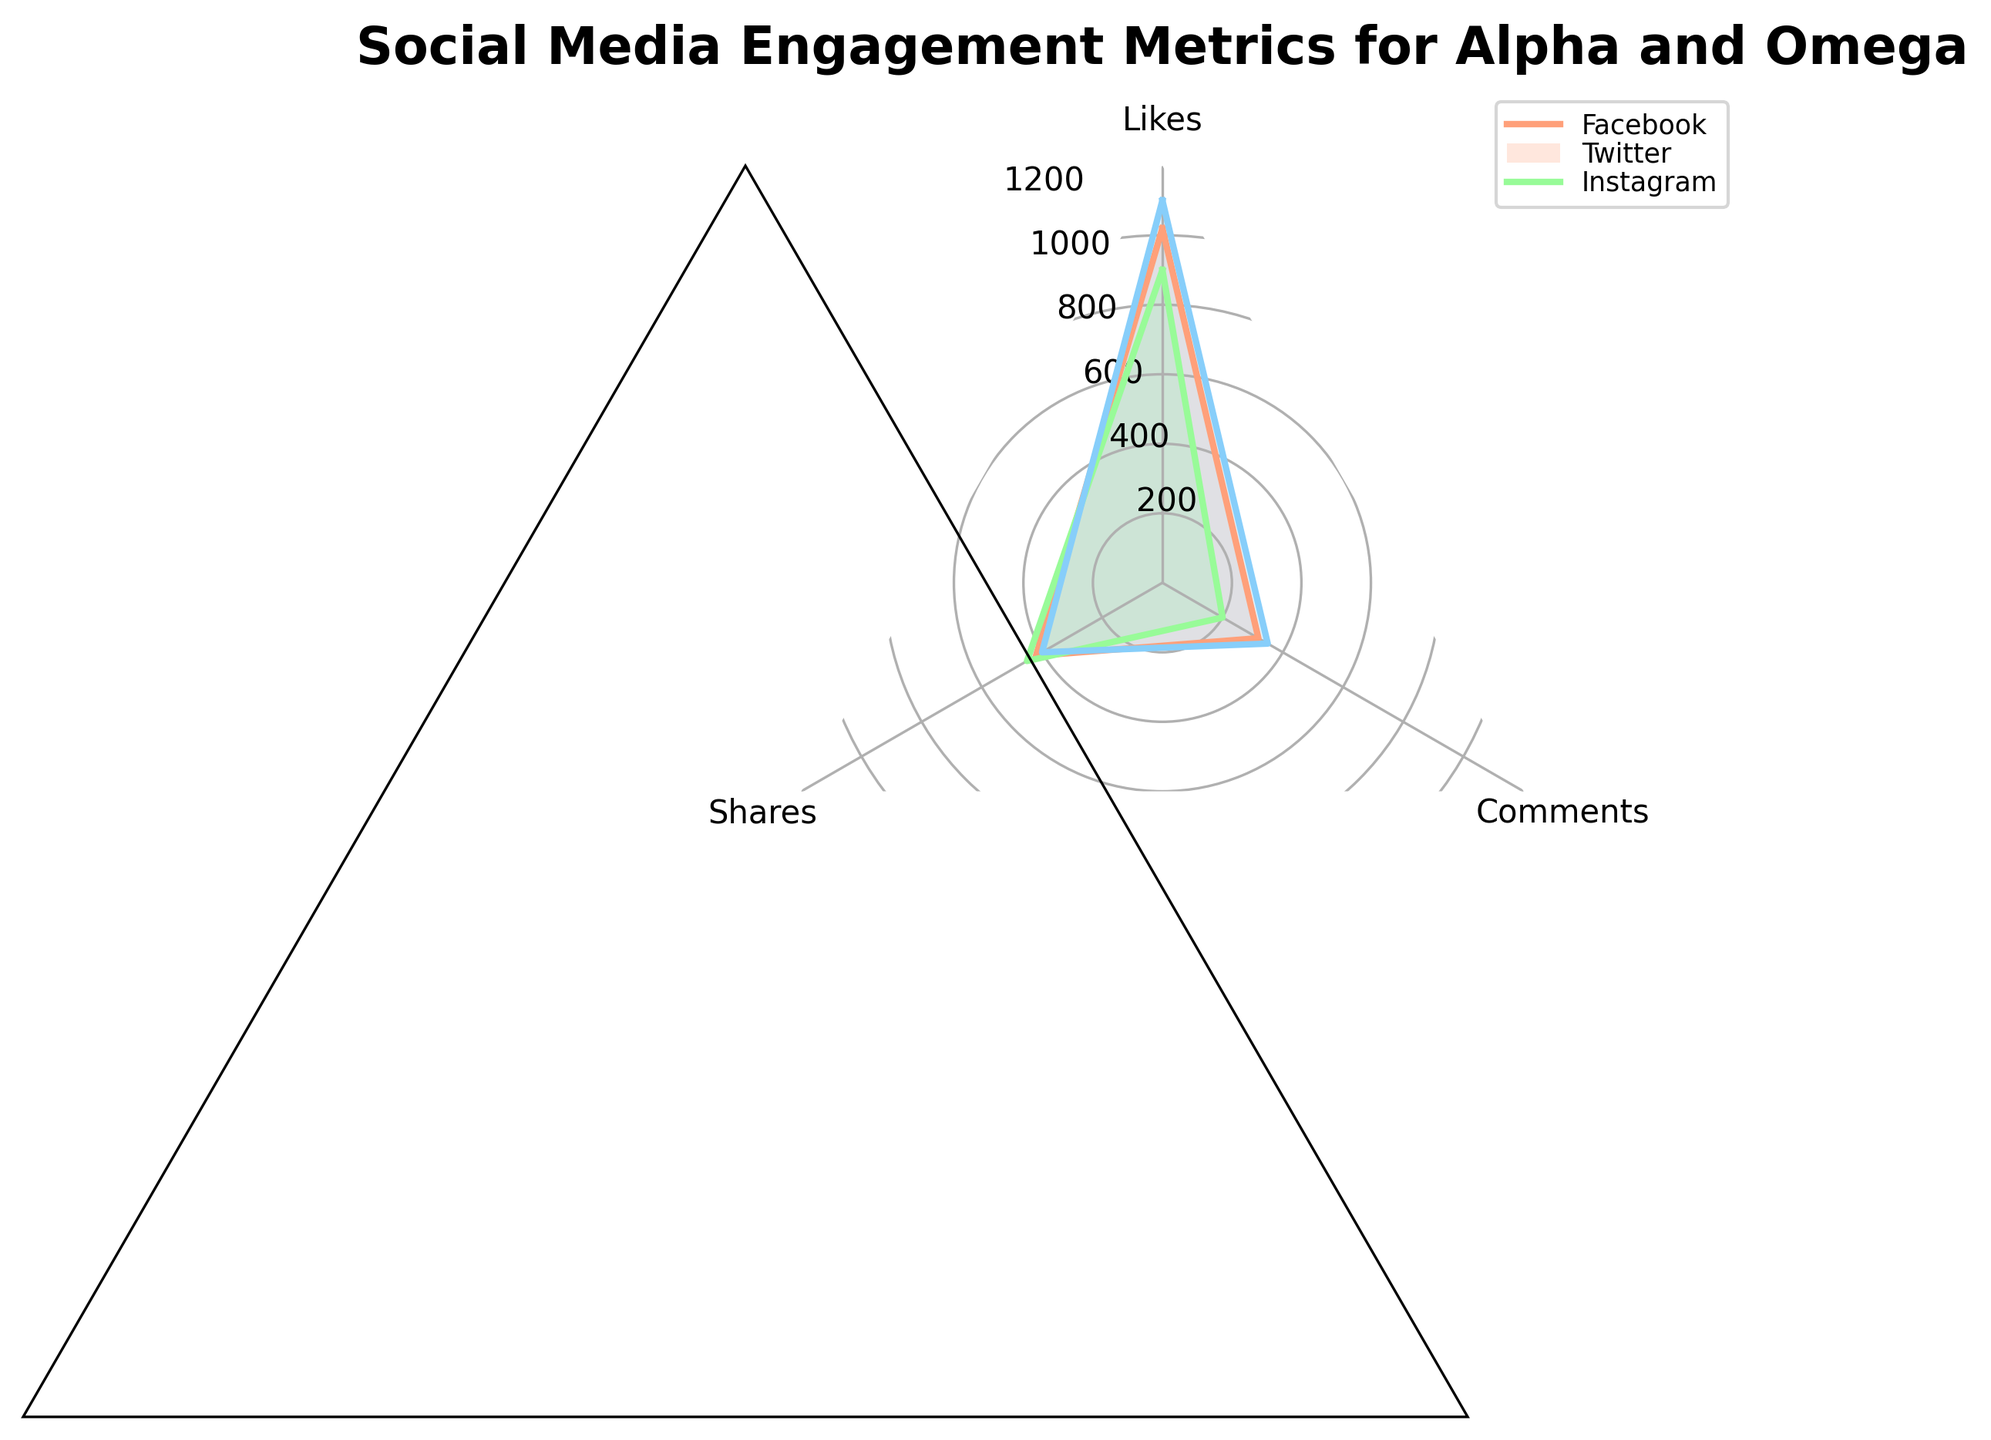What's the engagement metric with the highest value for Facebook's MovieClips? The radar chart shows likes, shares, and comments for Facebook's MovieClips. The highest value is found by comparing the three metrics. Likes is 1020 (highest), shares is 420, and comments is 319.
Answer: Likes Which platform has the highest average likes for FanArt? Calculate the average likes for FanArt on Facebook, Twitter, and Instagram. Facebook has 850 likes, Twitter has 750, and Instagram has 980. The average likes are highest on Instagram.
Answer: Instagram Which engagement metric shows more disparity between platforms for EventPosts? To determine the metric with more disparity, compare the spread of values. Likes for EventPosts are 650 (Facebook), 580 (Twitter), and 720 (Instagram). Shares are 251 (Facebook), 290 (Twitter), and 250 (Instagram). Comments are 190, 160, and 200. Likes (140 disparity), Shares (40 disparity), Comments (40 disparity).
Answer: Likes What is the ranking of platforms by number of comments for MovieClips, from highest to lowest? Compare the comments for MovieClips across platforms: Facebook (319), Twitter (200), and Instagram (350). Rank them from highest to lowest: Instagram, Facebook, Twitter.
Answer: Instagram, Facebook, Twitter Does Twitter's EventPosts have more comments than Instagram's EventPosts? Compare the comments for Twitter's EventPosts (160) with Instagram's EventPosts (200). Since 160 < 200, Twitter has fewer comments.
Answer: No Which platform's FanArt posts have the closest number of shares to its MovieClips? Compare the shares for FanArt and MovieClips on each platform. Facebook: FanArt (512), MovieClips (420); Twitter: FanArt (320), MovieClips (450); Instagram: FanArt (510), MovieClips (400). The smallest difference is on Instagram (110).
Answer: Instagram What’s the total number of likes for EventPosts across all platforms? Sum the likes for EventPosts on Facebook (650), Twitter (580), and Instagram (720). The total is 650 + 580 + 720 = 1950.
Answer: 1950 Which social media platform has the least variation in shares for MovieClips and FanArt? Calculate the difference in shares for MovieClips and FanArt on each platform. Facebook: 420 (MovieClips) - 512 (FanArt) = 92, Twitter: 450 - 320 = 130, Instagram: 400 - 510 = 110. Facebook has the least variation, 92.
Answer: Facebook On which platform do MovieClips receive the highest proportion of comments compared to likes? Calculate the proportion of comments to likes for MovieClips on each platform. Facebook: 319/1020 ≈ 0.313, Twitter: 200/900 ≈ 0.222, Instagram: 350/1100 ≈ 0.318. Instagram has the highest proportion.
Answer: Instagram 